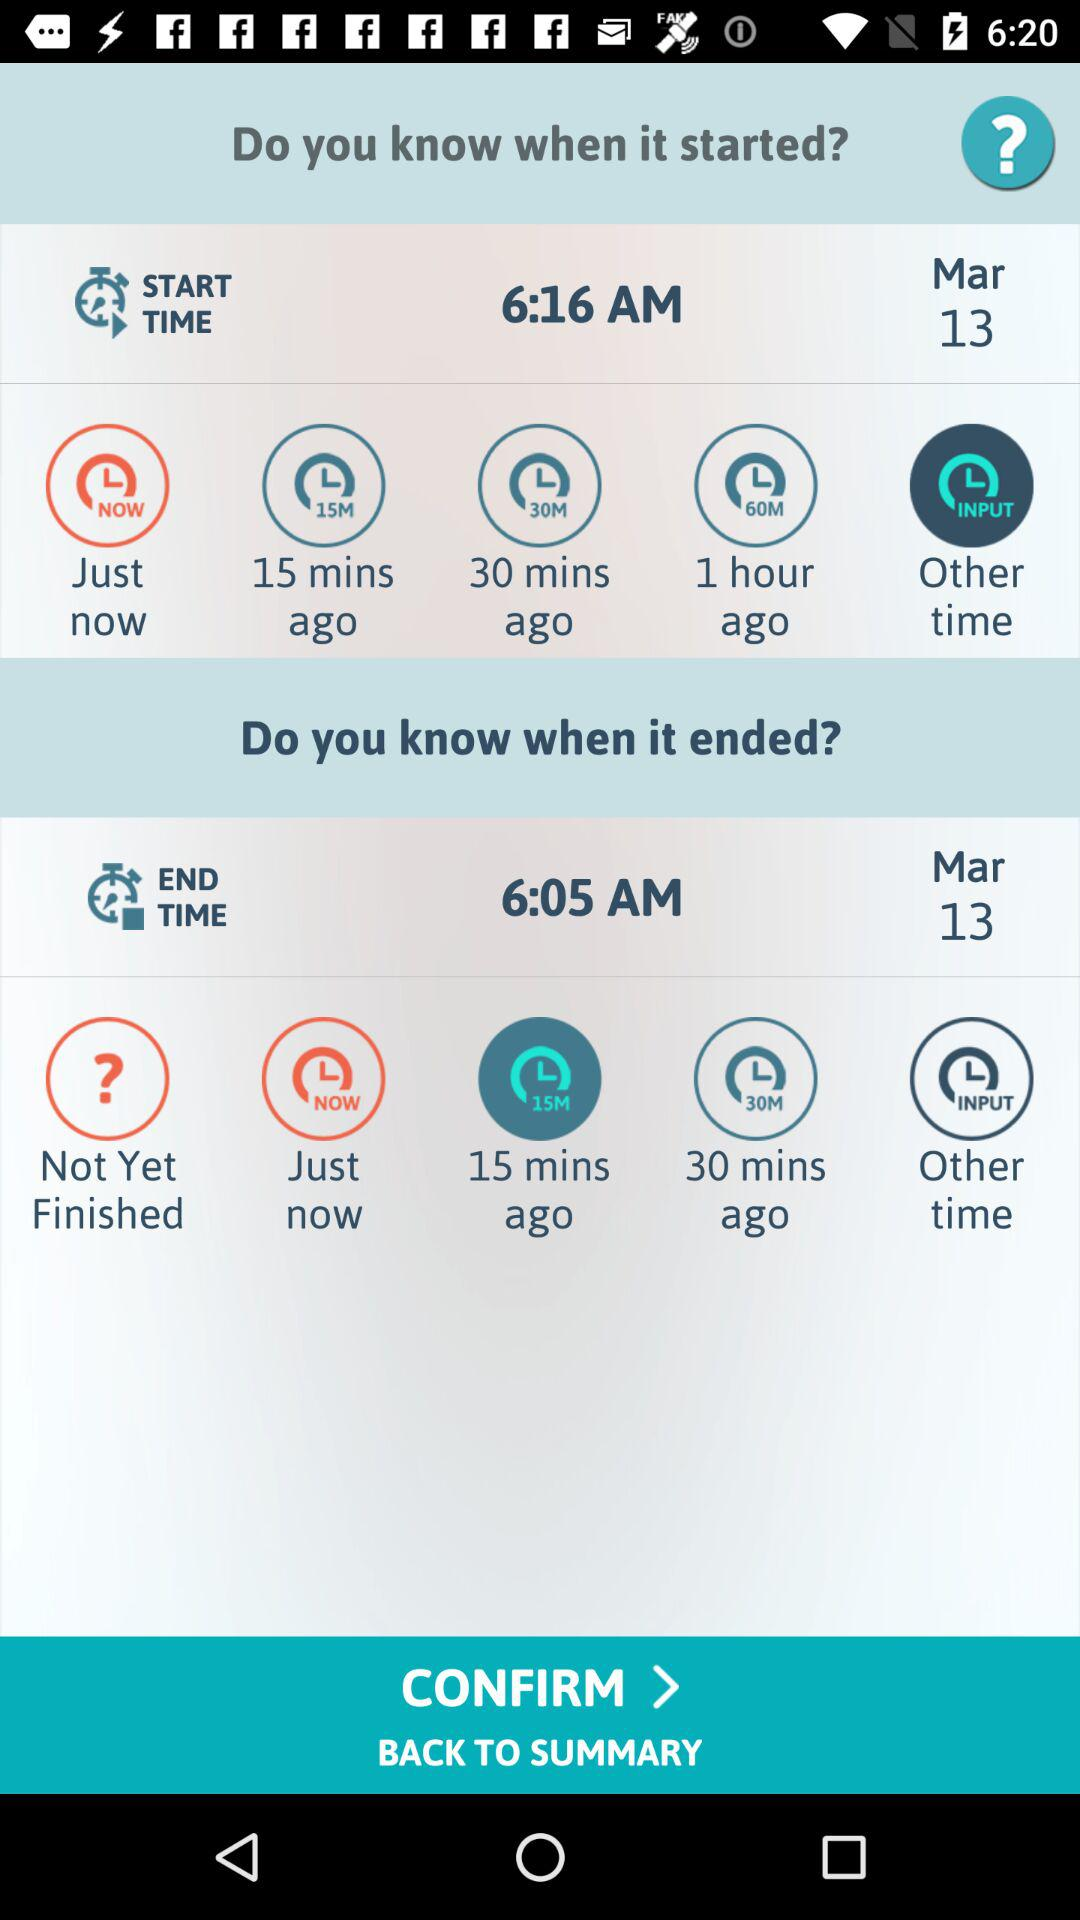What "ended" option has been selected? The selected option is 15 minutes ago. 